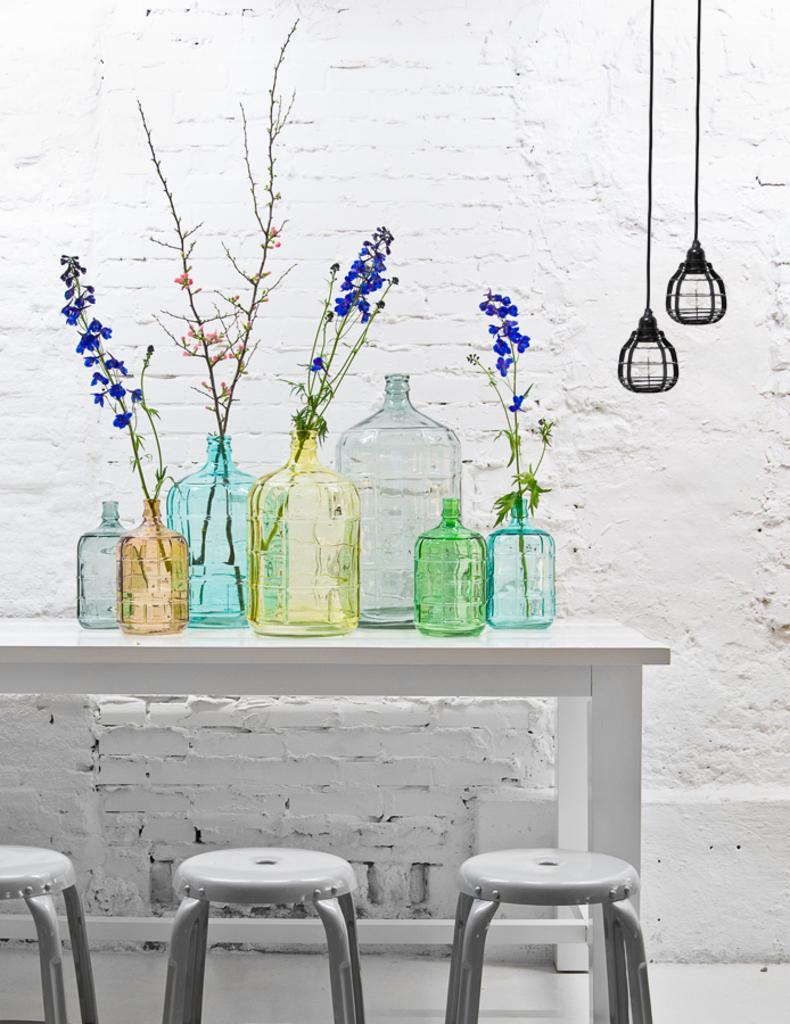Describe this image in one or two sentences. There are many stools and a table. On the table there are many bottle. Inside the bottle there are flowers, stems. Also in the background there is a brick wall. And there are two lamps hanged 